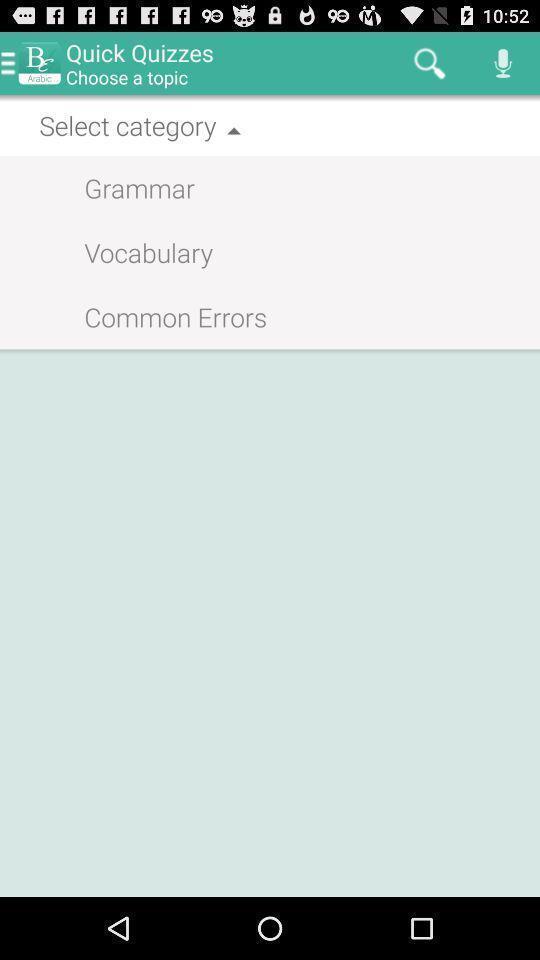Describe the content in this image. Screen displaying category to select. 